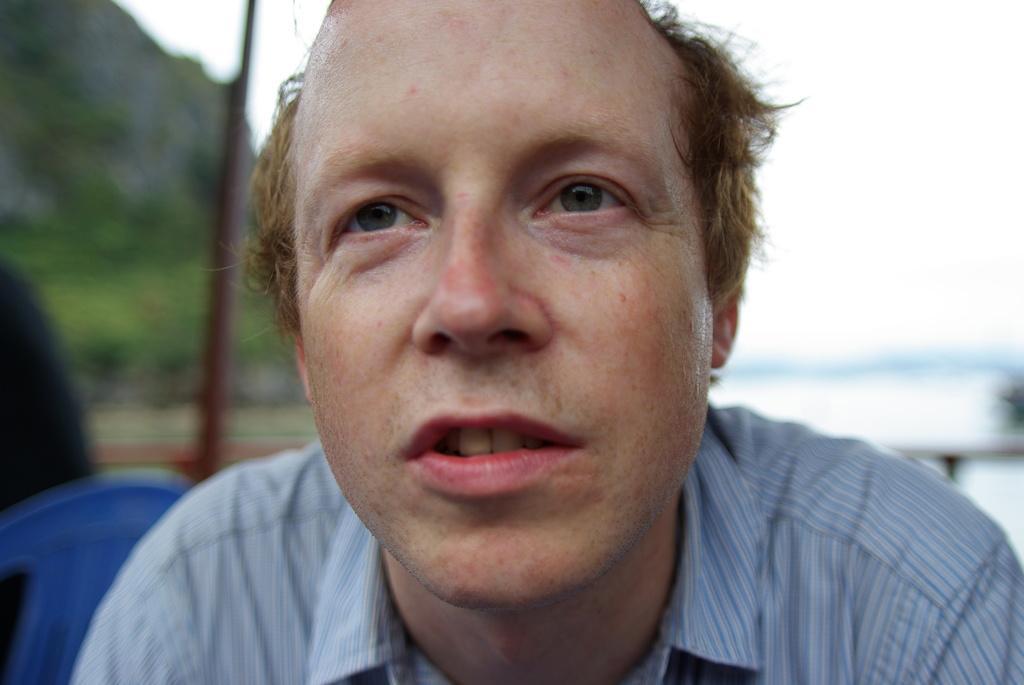Please provide a concise description of this image. In this image I can see the person with blue color dress. To the left I can see the blue color chair. And there is a blurred background. 